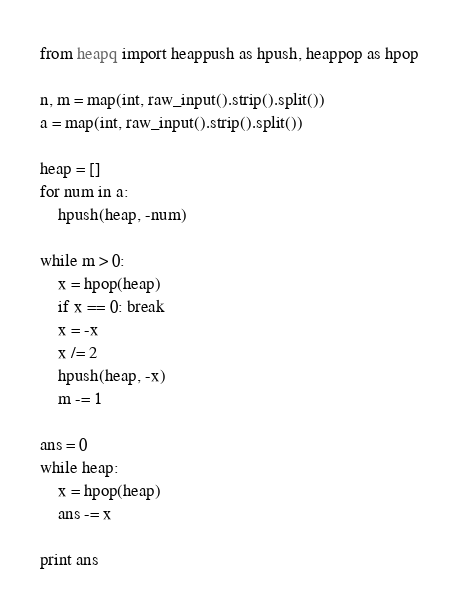Convert code to text. <code><loc_0><loc_0><loc_500><loc_500><_Python_>from heapq import heappush as hpush, heappop as hpop

n, m = map(int, raw_input().strip().split())
a = map(int, raw_input().strip().split())

heap = []
for num in a:
    hpush(heap, -num)

while m > 0:
    x = hpop(heap)
    if x == 0: break
    x = -x
    x /= 2
    hpush(heap, -x)
    m -= 1

ans = 0
while heap:
    x = hpop(heap)
    ans -= x

print ans</code> 